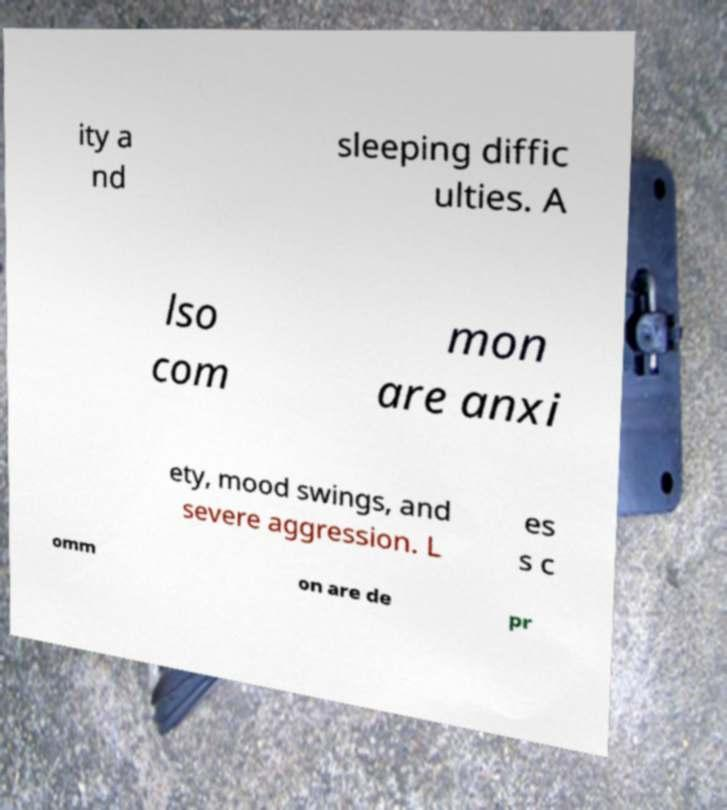I need the written content from this picture converted into text. Can you do that? ity a nd sleeping diffic ulties. A lso com mon are anxi ety, mood swings, and severe aggression. L es s c omm on are de pr 